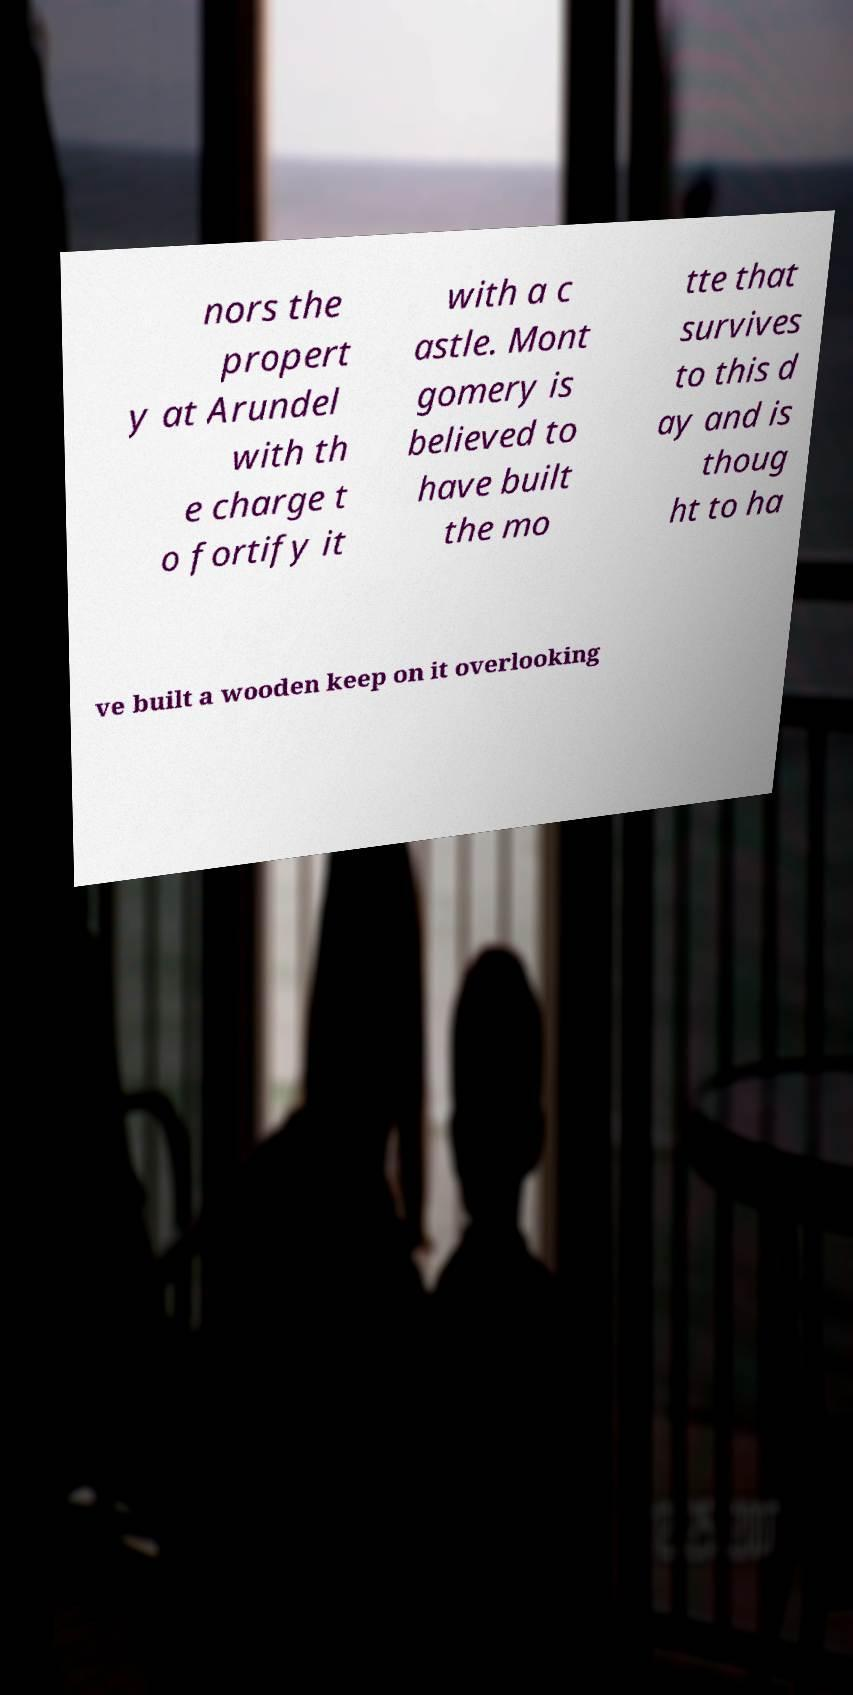I need the written content from this picture converted into text. Can you do that? nors the propert y at Arundel with th e charge t o fortify it with a c astle. Mont gomery is believed to have built the mo tte that survives to this d ay and is thoug ht to ha ve built a wooden keep on it overlooking 